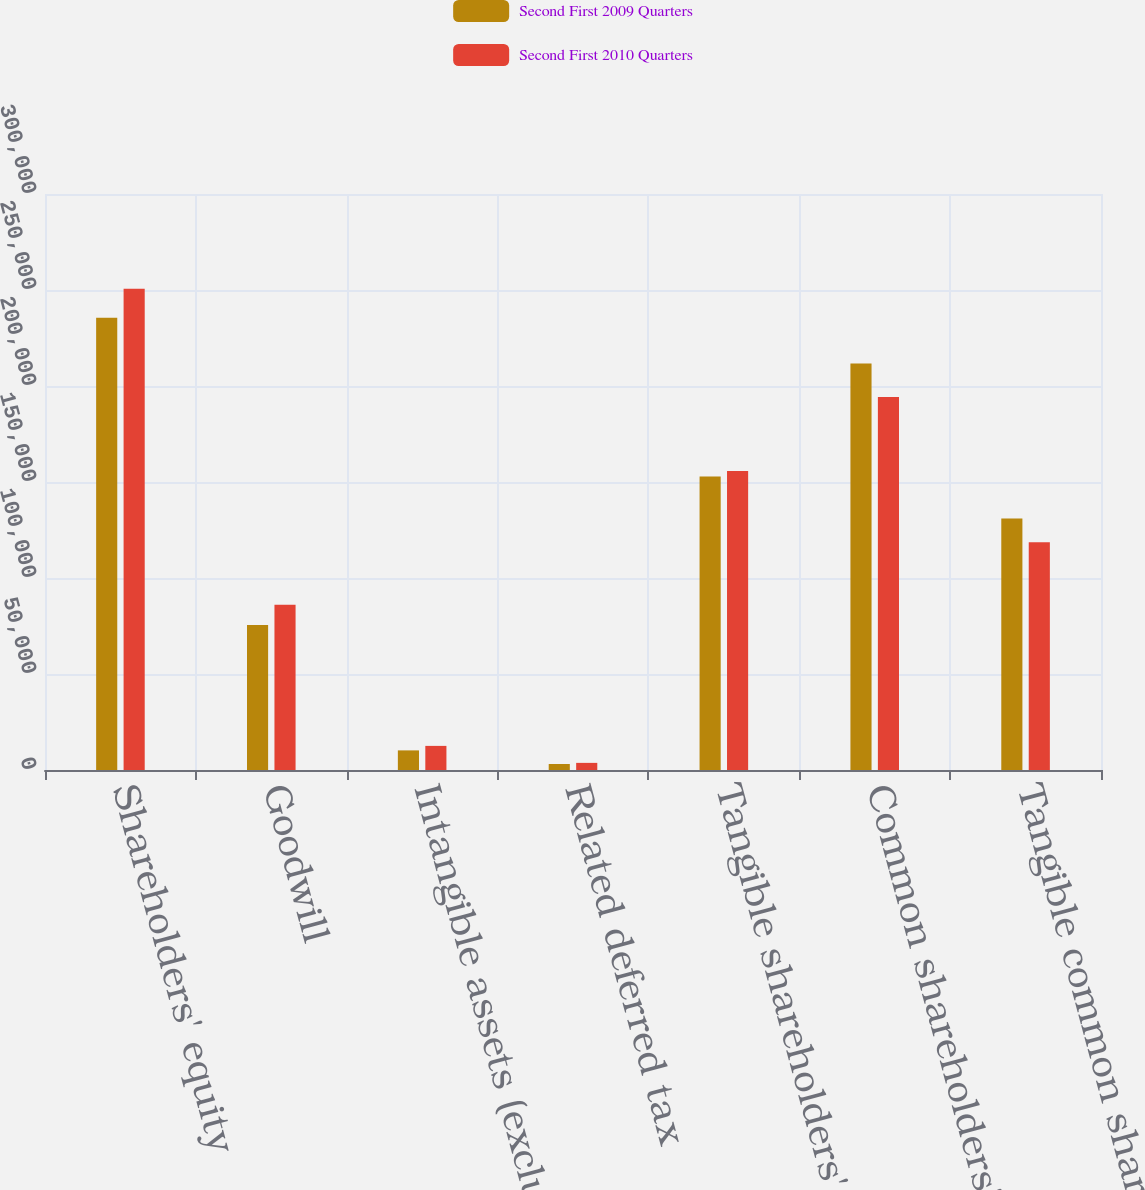Convert chart to OTSL. <chart><loc_0><loc_0><loc_500><loc_500><stacked_bar_chart><ecel><fcel>Shareholders' equity<fcel>Goodwill<fcel>Intangible assets (excluding<fcel>Related deferred tax<fcel>Tangible shareholders' equity<fcel>Common shareholders' equity<fcel>Tangible common shareholders'<nl><fcel>Second First 2009 Quarters<fcel>235525<fcel>75584<fcel>10211<fcel>3121<fcel>152851<fcel>211686<fcel>130938<nl><fcel>Second First 2010 Quarters<fcel>250599<fcel>86053<fcel>12556<fcel>3712<fcel>155702<fcel>194236<fcel>118638<nl></chart> 